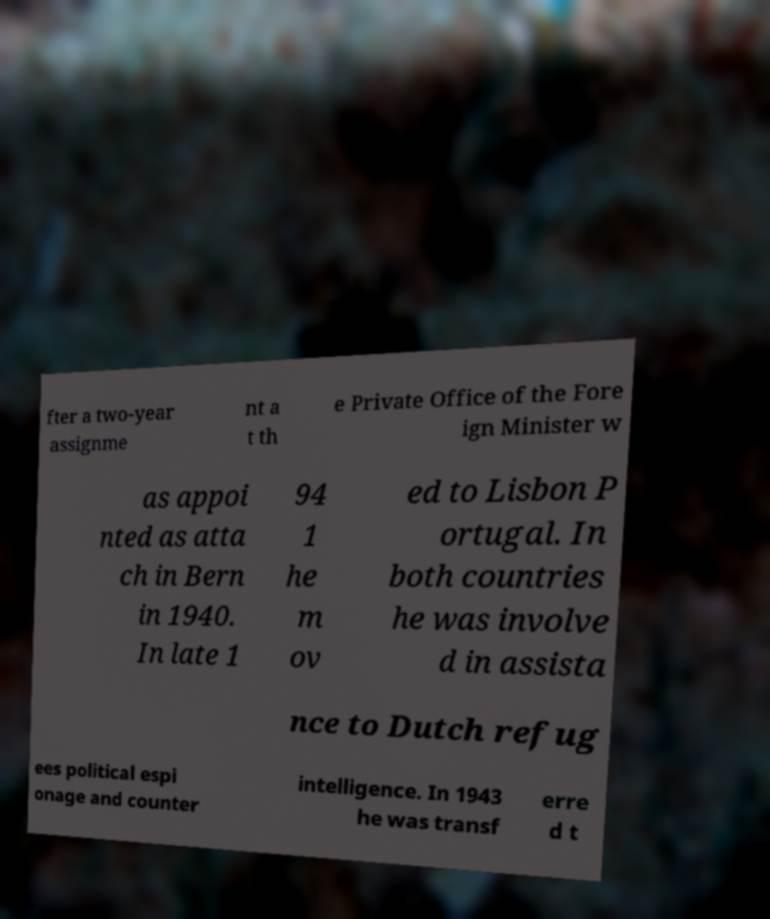For documentation purposes, I need the text within this image transcribed. Could you provide that? fter a two-year assignme nt a t th e Private Office of the Fore ign Minister w as appoi nted as atta ch in Bern in 1940. In late 1 94 1 he m ov ed to Lisbon P ortugal. In both countries he was involve d in assista nce to Dutch refug ees political espi onage and counter intelligence. In 1943 he was transf erre d t 